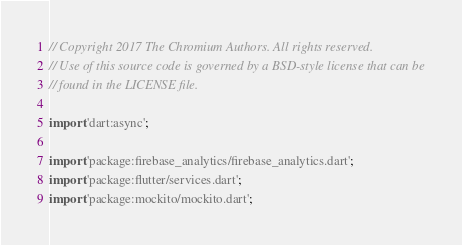Convert code to text. <code><loc_0><loc_0><loc_500><loc_500><_Dart_>// Copyright 2017 The Chromium Authors. All rights reserved.
// Use of this source code is governed by a BSD-style license that can be
// found in the LICENSE file.

import 'dart:async';

import 'package:firebase_analytics/firebase_analytics.dart';
import 'package:flutter/services.dart';
import 'package:mockito/mockito.dart';</code> 